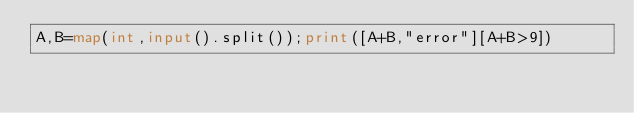Convert code to text. <code><loc_0><loc_0><loc_500><loc_500><_Python_>A,B=map(int,input().split());print([A+B,"error"][A+B>9])</code> 